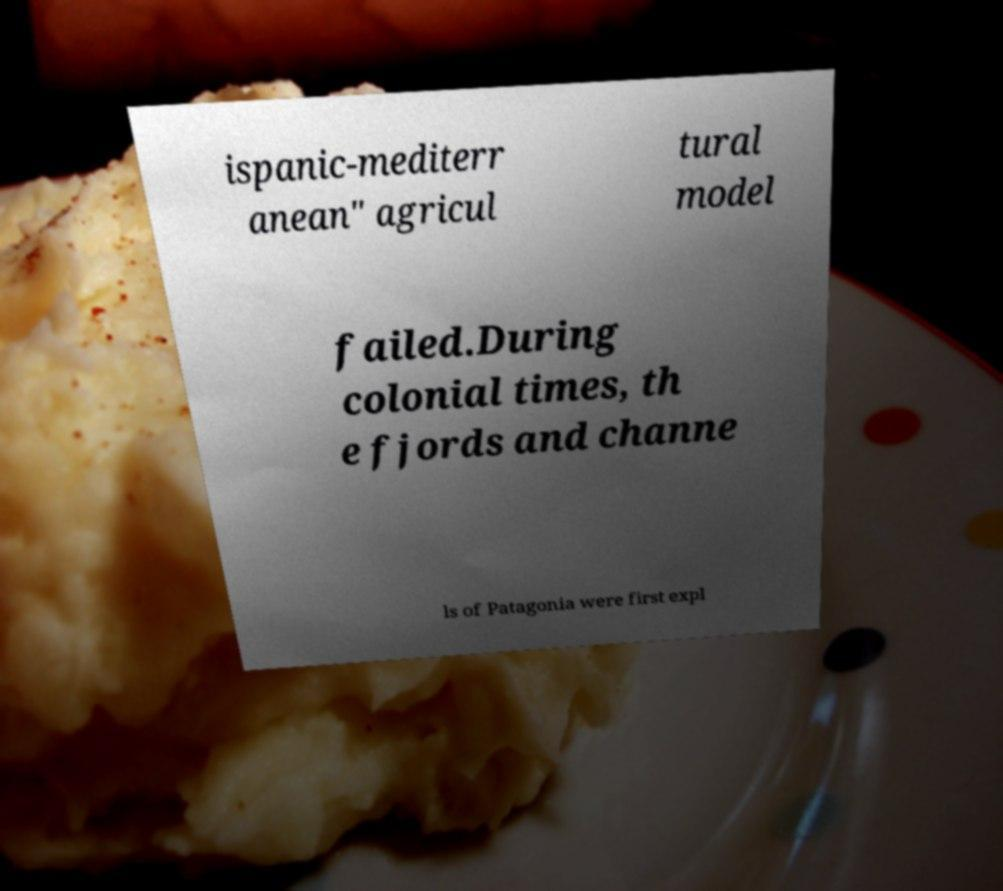There's text embedded in this image that I need extracted. Can you transcribe it verbatim? ispanic-mediterr anean" agricul tural model failed.During colonial times, th e fjords and channe ls of Patagonia were first expl 